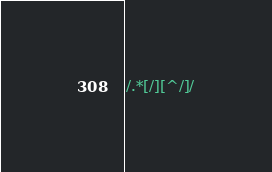Convert code to text. <code><loc_0><loc_0><loc_500><loc_500><_Awk_>/.*[/][^/]/</code> 